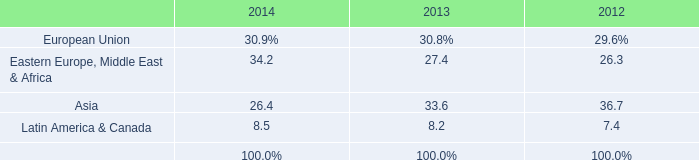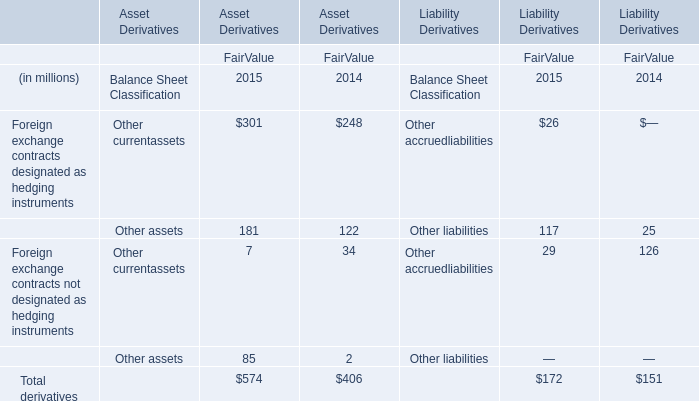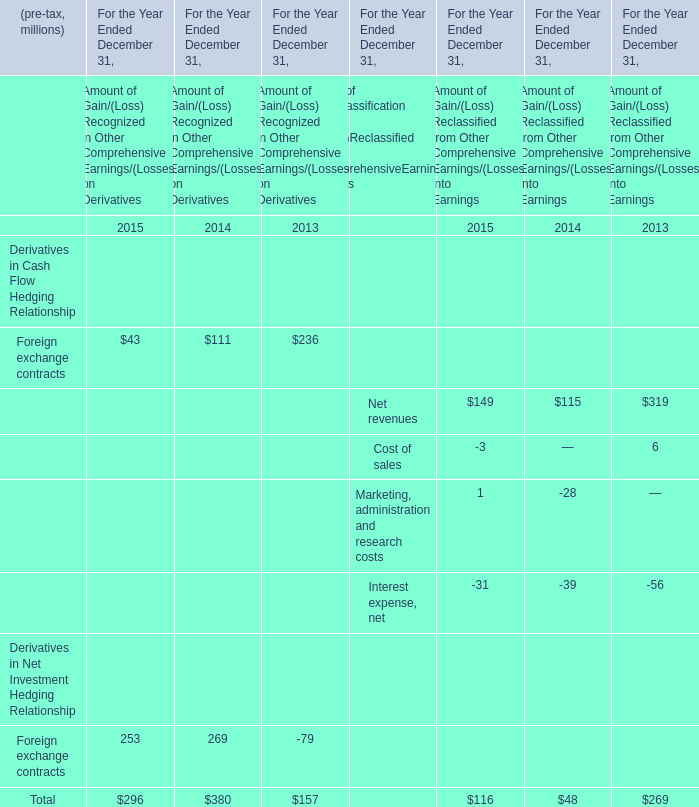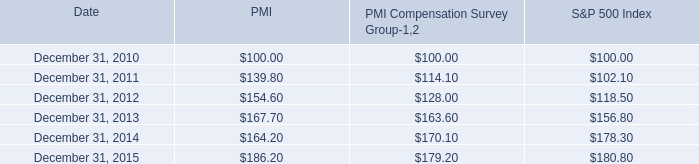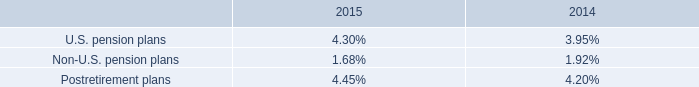what is the interest expense in 2015 assuming that all the debt is interest bearing debt , ( in billions ) ? 
Computations: (28.5 * 3.0%)
Answer: 0.855. 